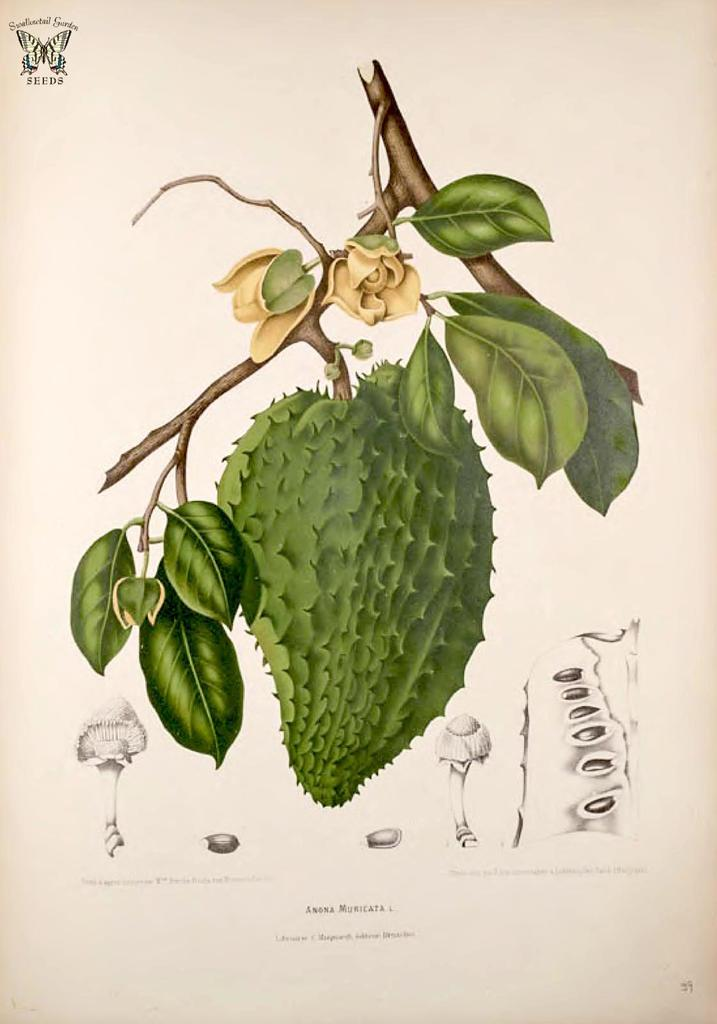What type of food can be seen in the image? The image contains a fruit. What is present on the fruit in the image? There are leaves in the image. What disease is affecting the fruit in the image? There is no indication of any disease affecting the fruit in the image. Can you see any ants on the fruit in the image? There are no ants visible in the image. 